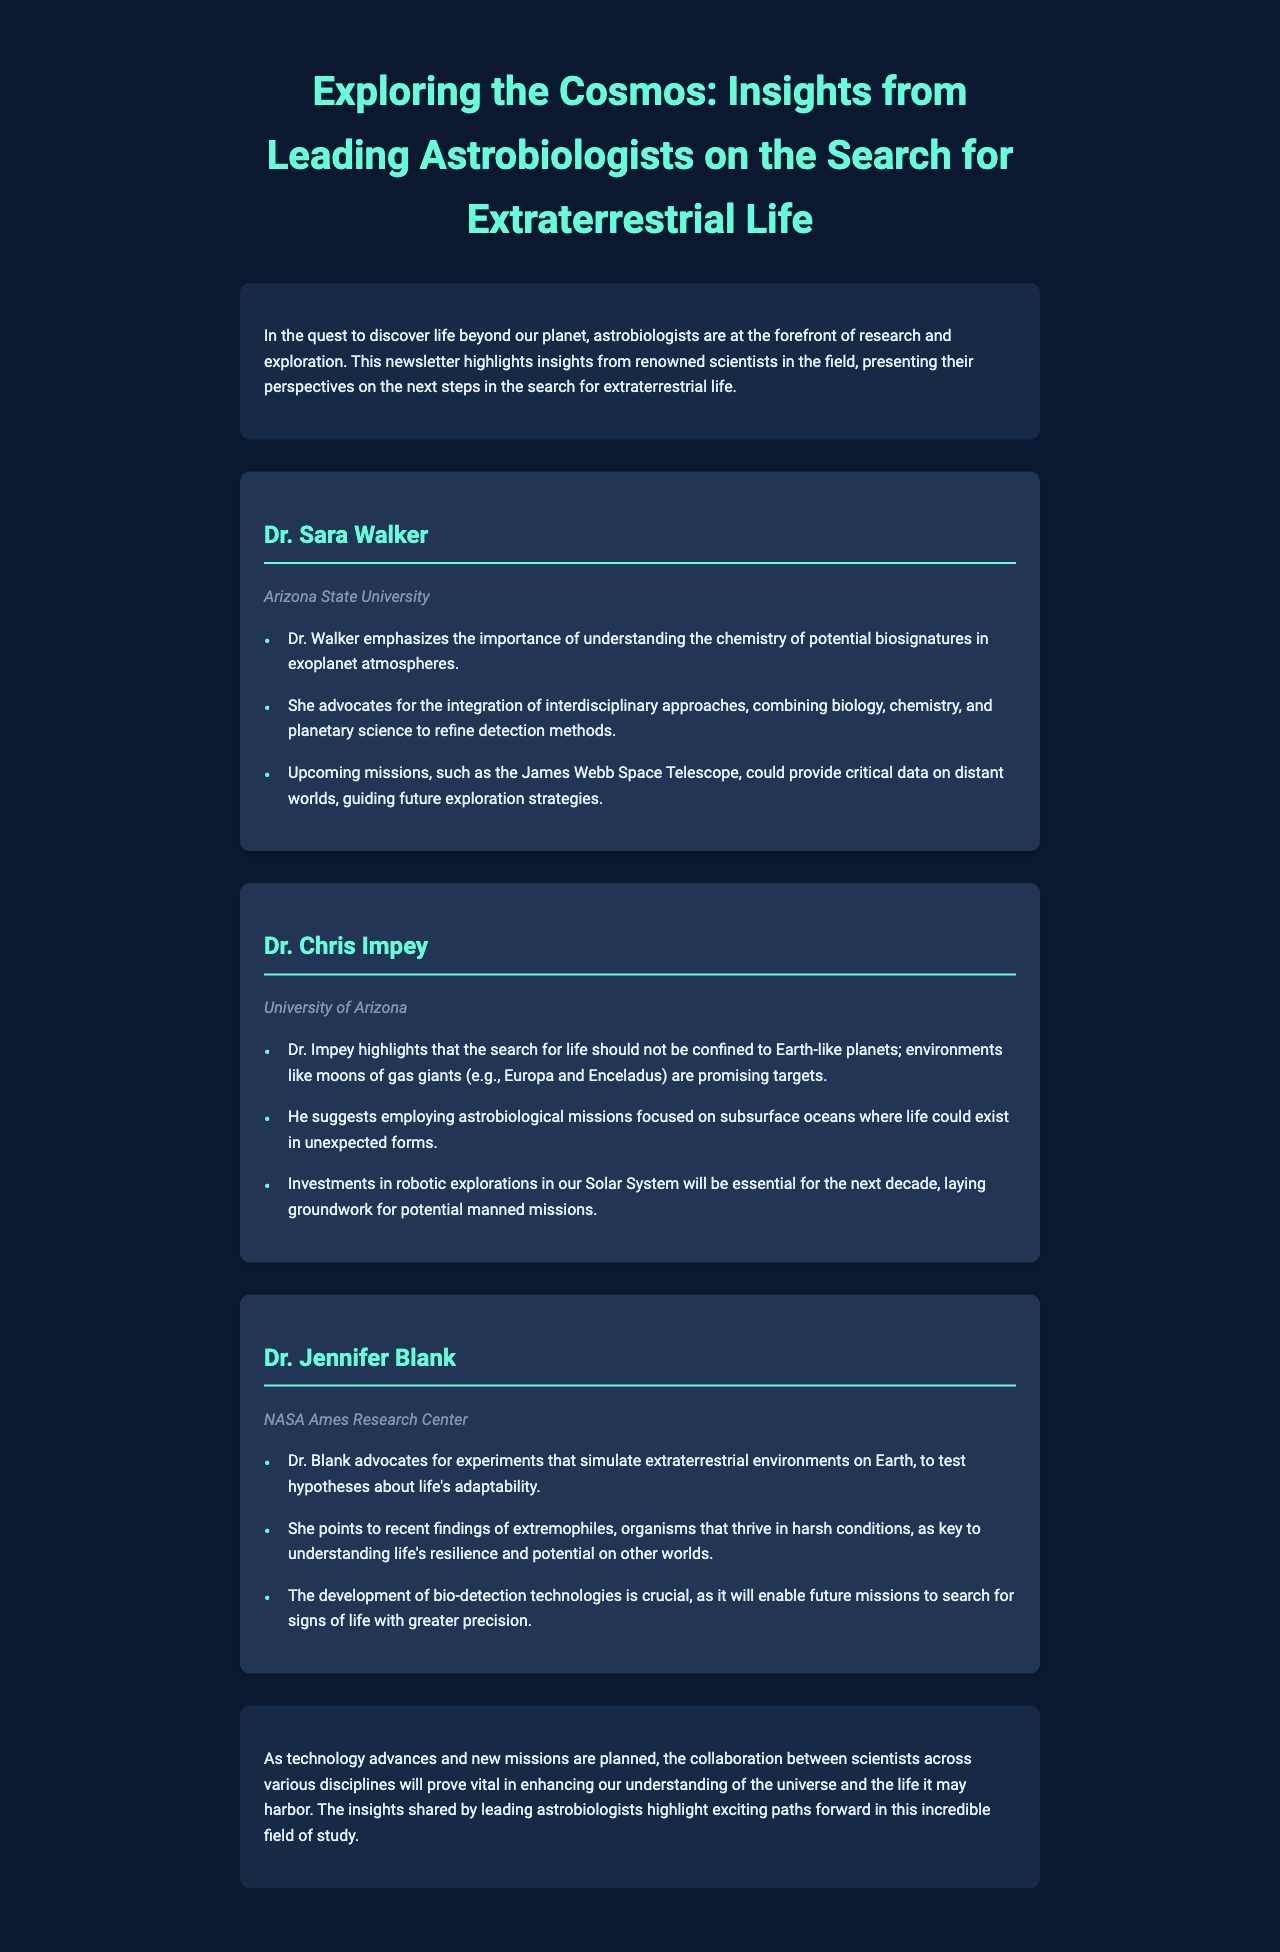What is the title of the newsletter? The title is stated at the top of the document, which introduces the main theme.
Answer: Exploring the Cosmos: Insights from Leading Astrobiologists on the Search for Extraterrestrial Life Who is affiliated with Arizona State University? Dr. Sara Walker is mentioned alongside her affiliation in the document.
Answer: Dr. Sara Walker Which telescope is expected to provide critical data on distant worlds? The document mentions an upcoming mission that is significant for future exploration strategies.
Answer: James Webb Space Telescope What type of organisms does Dr. Jennifer Blank mention in her interview? The document highlights specific organisms that thrive in harsh conditions and are important to understanding life's resilience.
Answer: Extremophiles What does Dr. Chris Impey suggest for future astrobiological missions? The document discusses specific environments that Dr. Impey finds promising for the search for life.
Answer: Subsurface oceans How many leading astrobiologists are interviewed in the document? The document features a total of three individuals sharing their insights and research directions.
Answer: Three 